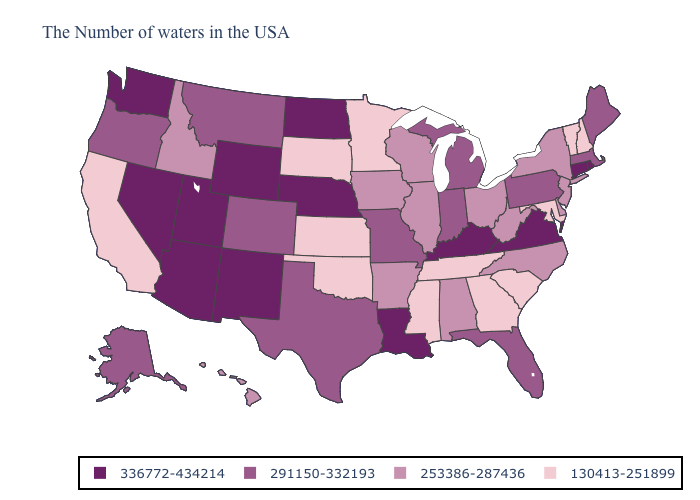Does Missouri have the lowest value in the USA?
Write a very short answer. No. Name the states that have a value in the range 130413-251899?
Short answer required. New Hampshire, Vermont, Maryland, South Carolina, Georgia, Tennessee, Mississippi, Minnesota, Kansas, Oklahoma, South Dakota, California. Does Maryland have the same value as Nevada?
Give a very brief answer. No. Among the states that border Wisconsin , does Minnesota have the lowest value?
Answer briefly. Yes. What is the lowest value in the MidWest?
Answer briefly. 130413-251899. Among the states that border Vermont , which have the lowest value?
Short answer required. New Hampshire. What is the highest value in states that border Tennessee?
Quick response, please. 336772-434214. Does Idaho have a higher value than Pennsylvania?
Answer briefly. No. What is the value of Nebraska?
Answer briefly. 336772-434214. Name the states that have a value in the range 291150-332193?
Be succinct. Maine, Massachusetts, Pennsylvania, Florida, Michigan, Indiana, Missouri, Texas, Colorado, Montana, Oregon, Alaska. Does Georgia have the lowest value in the USA?
Answer briefly. Yes. What is the value of Minnesota?
Concise answer only. 130413-251899. Does Arkansas have the lowest value in the South?
Write a very short answer. No. Does North Carolina have a lower value than Arkansas?
Keep it brief. No. Does Tennessee have the lowest value in the South?
Write a very short answer. Yes. 